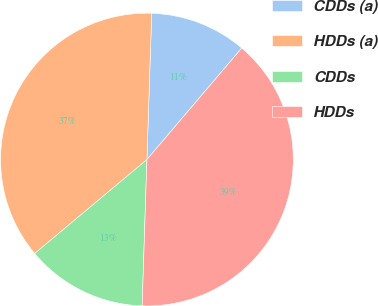<chart> <loc_0><loc_0><loc_500><loc_500><pie_chart><fcel>CDDs (a)<fcel>HDDs (a)<fcel>CDDs<fcel>HDDs<nl><fcel>10.7%<fcel>36.61%<fcel>13.39%<fcel>39.3%<nl></chart> 